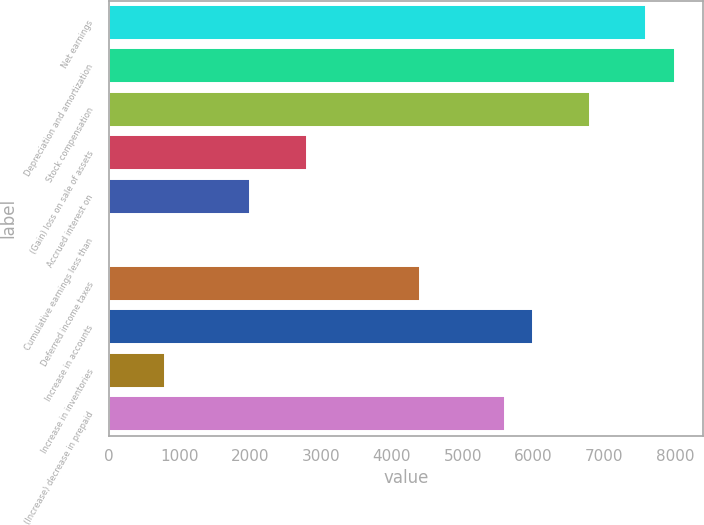<chart> <loc_0><loc_0><loc_500><loc_500><bar_chart><fcel>Net earnings<fcel>Depreciation and amortization<fcel>Stock compensation<fcel>(Gain) loss on sale of assets<fcel>Accrued interest on<fcel>Cumulative earnings less than<fcel>Deferred income taxes<fcel>Increase in accounts<fcel>Increase in inventories<fcel>(Increase) decrease in prepaid<nl><fcel>7590.22<fcel>7989.7<fcel>6791.26<fcel>2796.46<fcel>1997.5<fcel>0.1<fcel>4394.38<fcel>5992.3<fcel>799.06<fcel>5592.82<nl></chart> 